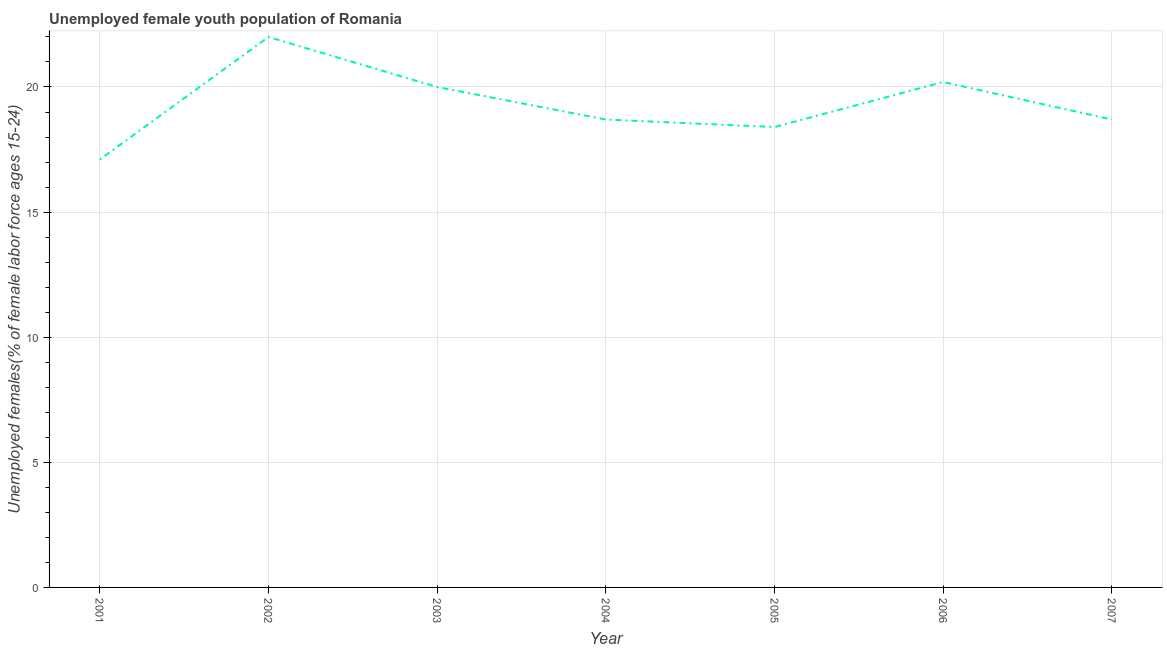What is the unemployed female youth in 2004?
Keep it short and to the point. 18.7. Across all years, what is the maximum unemployed female youth?
Offer a very short reply. 22. Across all years, what is the minimum unemployed female youth?
Your response must be concise. 17.1. What is the sum of the unemployed female youth?
Give a very brief answer. 135.1. What is the difference between the unemployed female youth in 2003 and 2006?
Give a very brief answer. -0.2. What is the average unemployed female youth per year?
Offer a terse response. 19.3. What is the median unemployed female youth?
Your answer should be compact. 18.7. In how many years, is the unemployed female youth greater than 10 %?
Keep it short and to the point. 7. What is the ratio of the unemployed female youth in 2002 to that in 2006?
Make the answer very short. 1.09. What is the difference between the highest and the second highest unemployed female youth?
Your answer should be compact. 1.8. What is the difference between the highest and the lowest unemployed female youth?
Provide a short and direct response. 4.9. In how many years, is the unemployed female youth greater than the average unemployed female youth taken over all years?
Provide a short and direct response. 3. Does the unemployed female youth monotonically increase over the years?
Make the answer very short. No. What is the difference between two consecutive major ticks on the Y-axis?
Offer a terse response. 5. Are the values on the major ticks of Y-axis written in scientific E-notation?
Your response must be concise. No. Does the graph contain any zero values?
Offer a terse response. No. Does the graph contain grids?
Offer a terse response. Yes. What is the title of the graph?
Your response must be concise. Unemployed female youth population of Romania. What is the label or title of the X-axis?
Offer a terse response. Year. What is the label or title of the Y-axis?
Your response must be concise. Unemployed females(% of female labor force ages 15-24). What is the Unemployed females(% of female labor force ages 15-24) of 2001?
Provide a short and direct response. 17.1. What is the Unemployed females(% of female labor force ages 15-24) in 2004?
Your answer should be compact. 18.7. What is the Unemployed females(% of female labor force ages 15-24) in 2005?
Make the answer very short. 18.4. What is the Unemployed females(% of female labor force ages 15-24) in 2006?
Offer a terse response. 20.2. What is the Unemployed females(% of female labor force ages 15-24) of 2007?
Make the answer very short. 18.7. What is the difference between the Unemployed females(% of female labor force ages 15-24) in 2001 and 2005?
Make the answer very short. -1.3. What is the difference between the Unemployed females(% of female labor force ages 15-24) in 2002 and 2005?
Your answer should be compact. 3.6. What is the difference between the Unemployed females(% of female labor force ages 15-24) in 2002 and 2007?
Ensure brevity in your answer.  3.3. What is the difference between the Unemployed females(% of female labor force ages 15-24) in 2003 and 2007?
Ensure brevity in your answer.  1.3. What is the difference between the Unemployed females(% of female labor force ages 15-24) in 2004 and 2005?
Provide a short and direct response. 0.3. What is the difference between the Unemployed females(% of female labor force ages 15-24) in 2004 and 2007?
Provide a short and direct response. 0. What is the difference between the Unemployed females(% of female labor force ages 15-24) in 2005 and 2007?
Offer a terse response. -0.3. What is the ratio of the Unemployed females(% of female labor force ages 15-24) in 2001 to that in 2002?
Offer a terse response. 0.78. What is the ratio of the Unemployed females(% of female labor force ages 15-24) in 2001 to that in 2003?
Offer a terse response. 0.85. What is the ratio of the Unemployed females(% of female labor force ages 15-24) in 2001 to that in 2004?
Your answer should be compact. 0.91. What is the ratio of the Unemployed females(% of female labor force ages 15-24) in 2001 to that in 2005?
Offer a very short reply. 0.93. What is the ratio of the Unemployed females(% of female labor force ages 15-24) in 2001 to that in 2006?
Keep it short and to the point. 0.85. What is the ratio of the Unemployed females(% of female labor force ages 15-24) in 2001 to that in 2007?
Your answer should be very brief. 0.91. What is the ratio of the Unemployed females(% of female labor force ages 15-24) in 2002 to that in 2003?
Your answer should be compact. 1.1. What is the ratio of the Unemployed females(% of female labor force ages 15-24) in 2002 to that in 2004?
Offer a terse response. 1.18. What is the ratio of the Unemployed females(% of female labor force ages 15-24) in 2002 to that in 2005?
Ensure brevity in your answer.  1.2. What is the ratio of the Unemployed females(% of female labor force ages 15-24) in 2002 to that in 2006?
Give a very brief answer. 1.09. What is the ratio of the Unemployed females(% of female labor force ages 15-24) in 2002 to that in 2007?
Give a very brief answer. 1.18. What is the ratio of the Unemployed females(% of female labor force ages 15-24) in 2003 to that in 2004?
Provide a succinct answer. 1.07. What is the ratio of the Unemployed females(% of female labor force ages 15-24) in 2003 to that in 2005?
Provide a succinct answer. 1.09. What is the ratio of the Unemployed females(% of female labor force ages 15-24) in 2003 to that in 2007?
Provide a short and direct response. 1.07. What is the ratio of the Unemployed females(% of female labor force ages 15-24) in 2004 to that in 2005?
Offer a very short reply. 1.02. What is the ratio of the Unemployed females(% of female labor force ages 15-24) in 2004 to that in 2006?
Give a very brief answer. 0.93. What is the ratio of the Unemployed females(% of female labor force ages 15-24) in 2005 to that in 2006?
Provide a succinct answer. 0.91. 